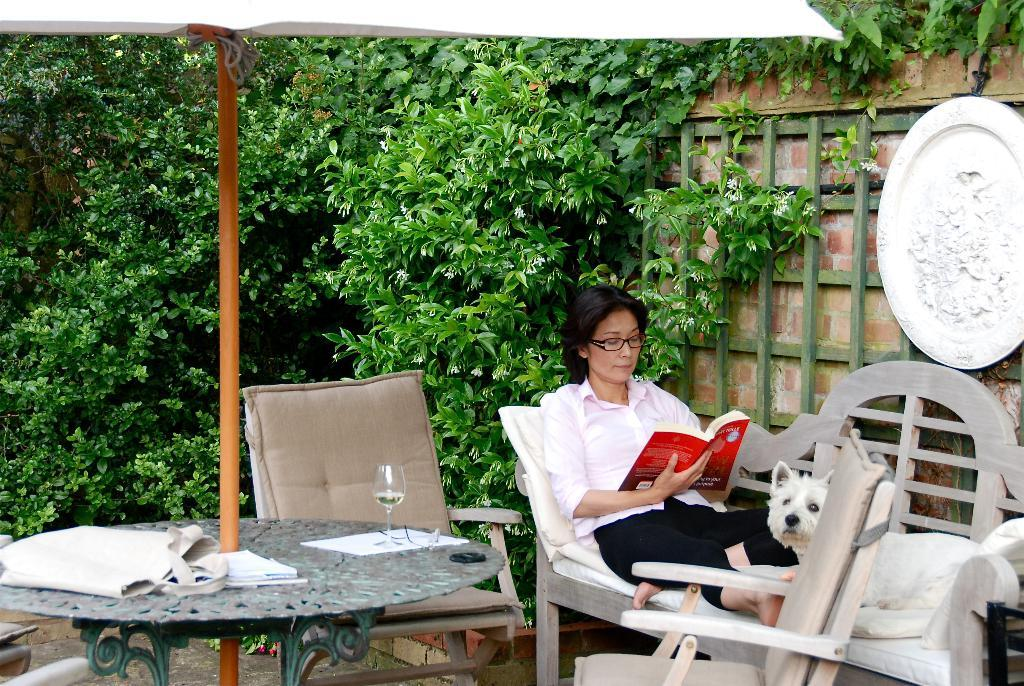What is the woman in the image doing? The woman is sitting on a bench and reading a book. Is there any animal present in the image? Yes, there is a dog beside the woman. What can be seen in the background of the image? There are trees, a table, chairs, and bags in the background of the image. What type of jam is the woman spreading on the cracker in the image? There is no jam or cracker present in the image. The woman is reading a book, and there is a dog beside her. 